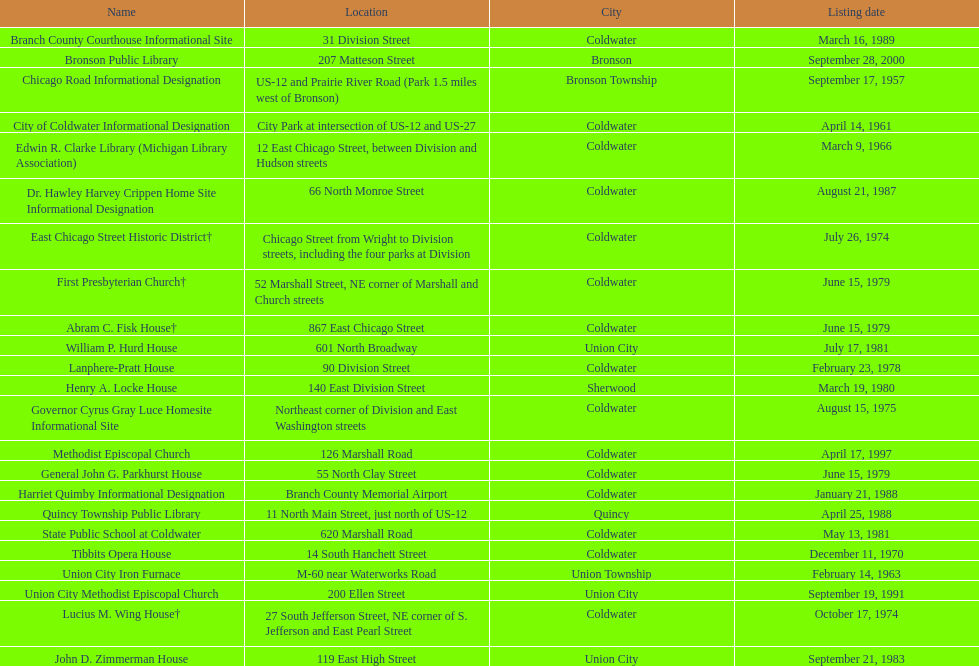What is the entire current catalog of names on this chart? 23. 